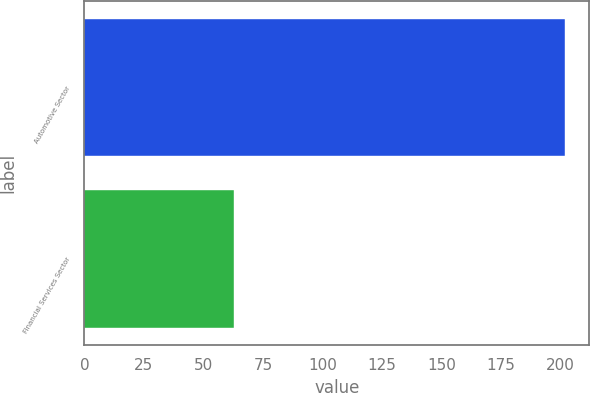Convert chart. <chart><loc_0><loc_0><loc_500><loc_500><bar_chart><fcel>Automotive Sector<fcel>Financial Services Sector<nl><fcel>202<fcel>63<nl></chart> 